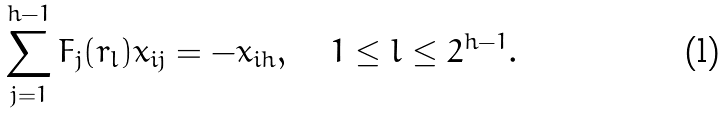Convert formula to latex. <formula><loc_0><loc_0><loc_500><loc_500>\sum _ { j = 1 } ^ { h - 1 } F _ { j } ( r _ { l } ) x _ { i j } = - x _ { i h } , \quad 1 \leq l \leq 2 ^ { h - 1 } .</formula> 